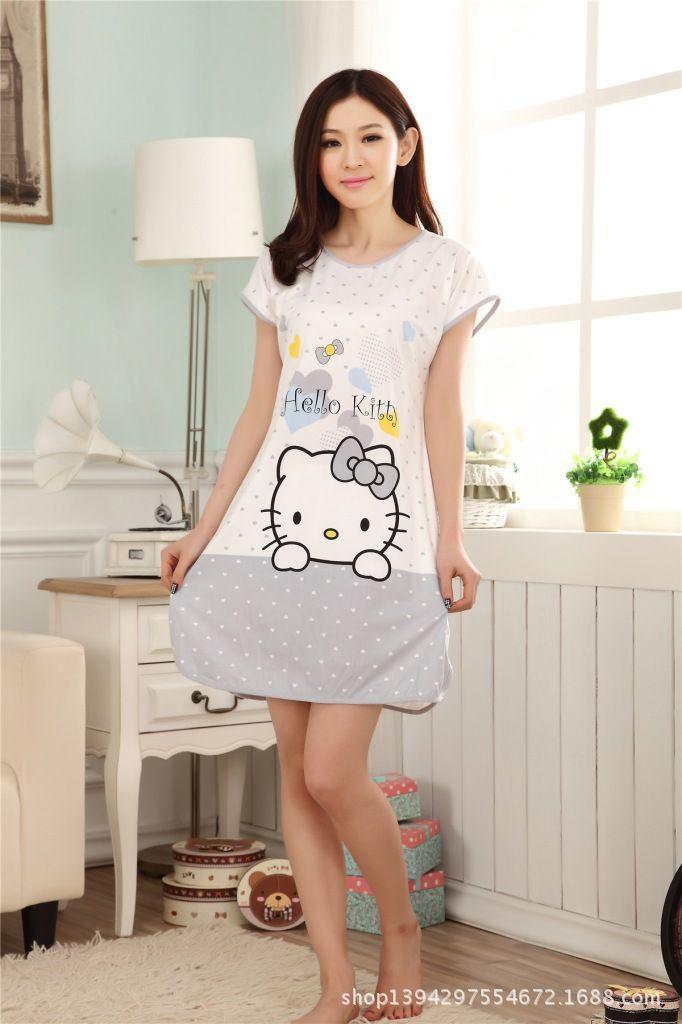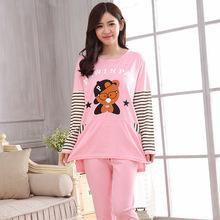The first image is the image on the left, the second image is the image on the right. Evaluate the accuracy of this statement regarding the images: "Both girls are standing up but only one of them is touching her face.". Is it true? Answer yes or no. No. The first image is the image on the left, the second image is the image on the right. Analyze the images presented: Is the assertion "All of the girls are wearing pajamas with cartoon characters on them." valid? Answer yes or no. Yes. 